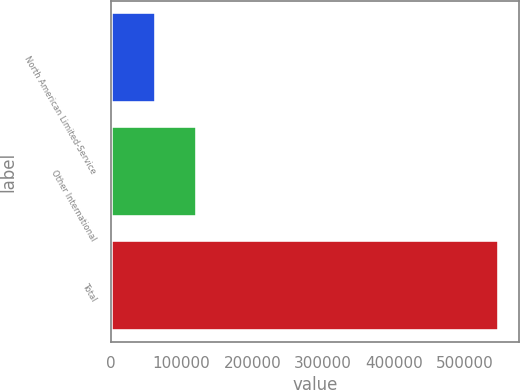Convert chart to OTSL. <chart><loc_0><loc_0><loc_500><loc_500><bar_chart><fcel>North American Limited-Service<fcel>Other International<fcel>Total<nl><fcel>64372<fcel>121508<fcel>549664<nl></chart> 